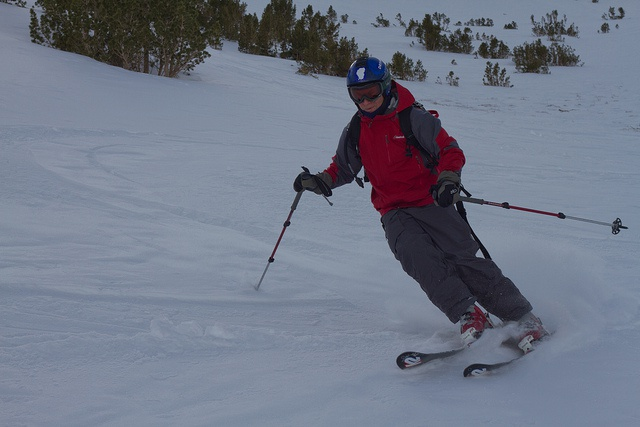Describe the objects in this image and their specific colors. I can see people in black, maroon, gray, and navy tones and skis in black and gray tones in this image. 